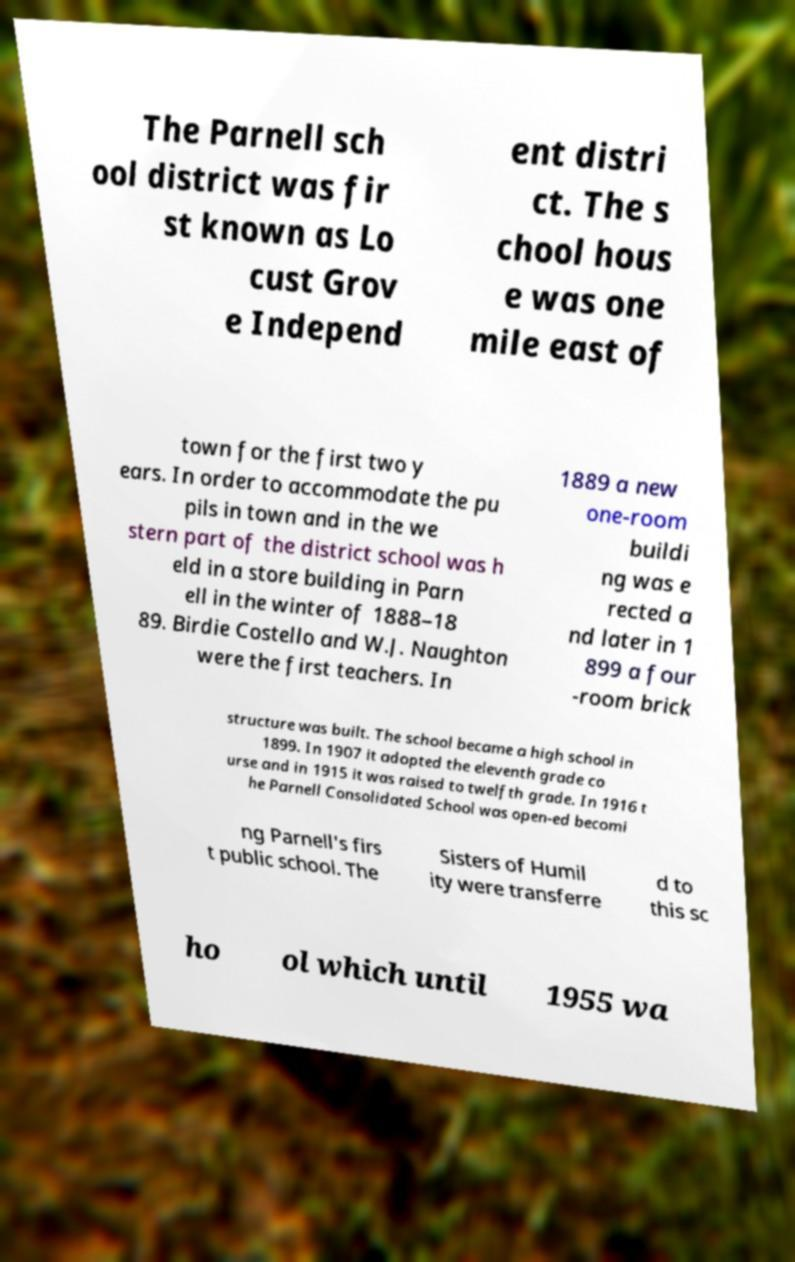What messages or text are displayed in this image? I need them in a readable, typed format. The Parnell sch ool district was fir st known as Lo cust Grov e Independ ent distri ct. The s chool hous e was one mile east of town for the first two y ears. In order to accommodate the pu pils in town and in the we stern part of the district school was h eld in a store building in Parn ell in the winter of 1888–18 89. Birdie Costello and W.J. Naughton were the first teachers. In 1889 a new one-room buildi ng was e rected a nd later in 1 899 a four -room brick structure was built. The school became a high school in 1899. In 1907 it adopted the eleventh grade co urse and in 1915 it was raised to twelfth grade. In 1916 t he Parnell Consolidated School was open-ed becomi ng Parnell's firs t public school. The Sisters of Humil ity were transferre d to this sc ho ol which until 1955 wa 